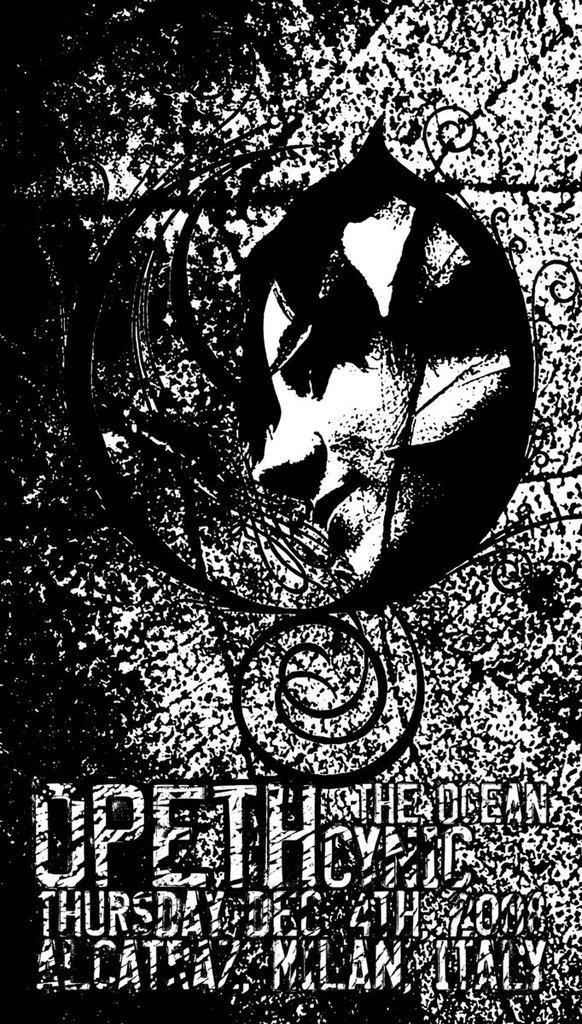Can you describe this image briefly? I see this image is black and white in color and I see the depiction of a person's face over here and I see something is written over here. 